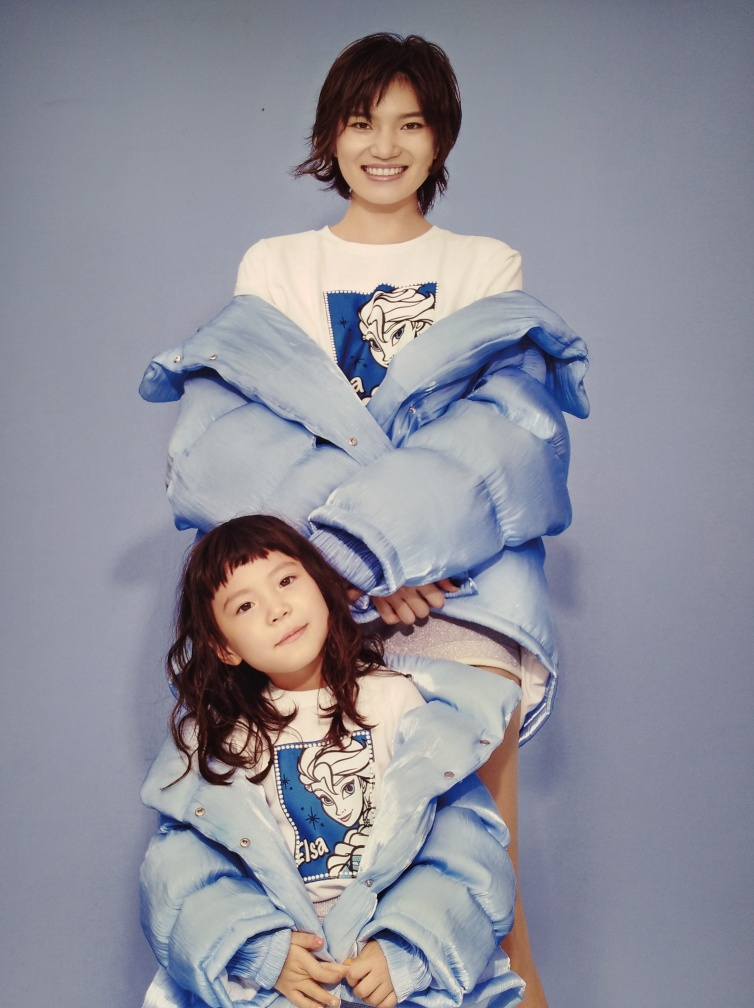Does the image have a particular theme or aesthetic? The image seems to convey a theme of joy and youthfulness. The bright colors, relaxed poses, and the oversized denim clothing come together to create an aesthetic that's both trendy and playful. This is accentuated by the solid color background that draws attention to the subjects and their clothing. 